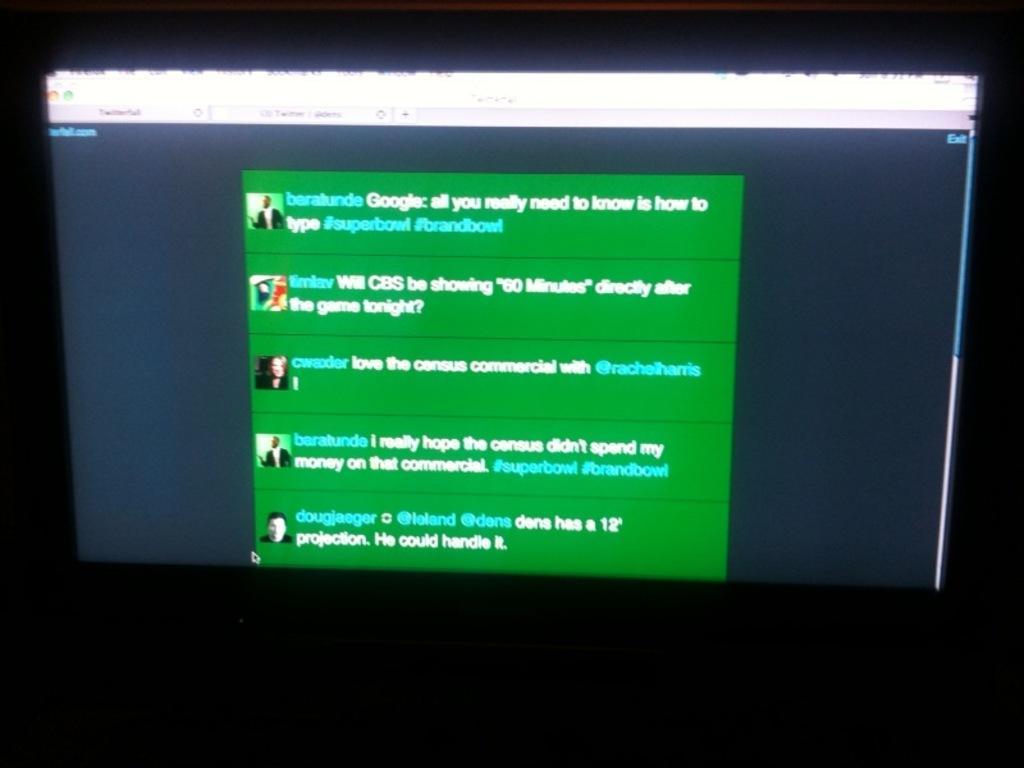Could you give a brief overview of what you see in this image? In this image we can see the screen which includes the text and images. 